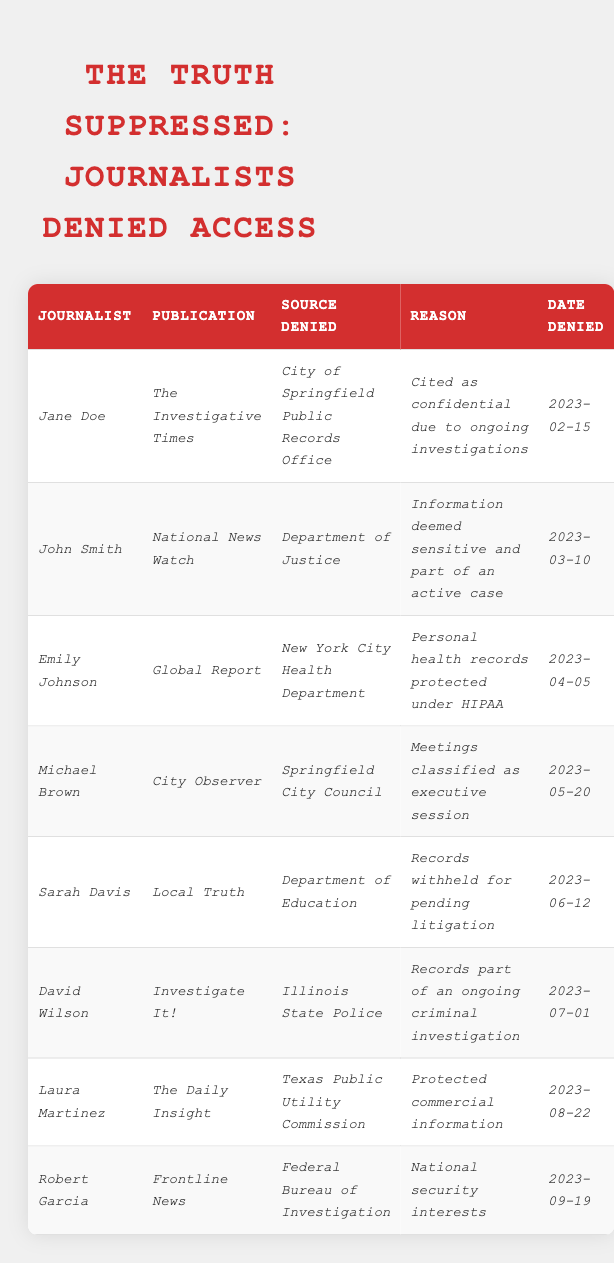What is the name of the journalist denied access by the Illinois State Police? The table lists journalists along with their denied access sources. For the Illinois State Police, the corresponding journalist is David Wilson.
Answer: David Wilson Which publication does Sarah Davis work for? By examining the table, Sarah Davis is shown to be associated with "Local Truth".
Answer: Local Truth How many journalists were denied access to sources in the year 2023? The table contains a list of 8 journalists, all of whom were denied access in 2023, as all dates are in that year.
Answer: 8 What reason was given for denying Jane Doe access to public records? The table details that Jane Doe was denied access because the records were "cited as confidential due to ongoing investigations".
Answer: Cited as confidential due to ongoing investigations Is the reason for denying access to the New York City Health Department related to HIPAA? Looking at the table, it states that Emily Johnson was denied access to the New York City Health Department due to "personal health records protected under HIPAA". Therefore, the answer is yes.
Answer: Yes List the sources that were denied access to public records by journalists in May 2023 or later. From the table, I will filter the dates; Michael Brown denied access in May 2023 and Sarah Davis, David Wilson, Laura Martinez, and Robert Garcia afterwards. The sources are the Springfield City Council, Department of Education, Illinois State Police, Texas Public Utility Commission, and the Federal Bureau of Investigation.
Answer: Springfield City Council, Department of Education, Illinois State Police, Texas Public Utility Commission, Federal Bureau of Investigation Which journalist was denied access on the earliest date among the listed incidents? We can refer to the "Date Denied" column in the table. The earliest date mentioned is February 15, 2023, belonging to Jane Doe.
Answer: Jane Doe What is the total number of denied access incidents due to ongoing investigations? The table shows two incidents related to ongoing investigations: one for Jane Doe with the Springfield Public Records Office and another for David Wilson with Illinois State Police.
Answer: 2 Which publication faced denied access related to national security interests? The table indicates that Robert Garcia from "Frontline News" was denied access due to national security interests, as per the corresponding entry.
Answer: Frontline News What was the most frequently cited reason for denial of access among the journalists listed? Examining the reasons, "ongoing investigations" and "protected personal information" appear twice among the reasons. However, each specific reason has a unique description. Thus, the most common reason in different variations appears to be associated with active investigations.
Answer: Ongoing investigations Were any journalists denied access to records related to education? Sarah Davis was denied records from the Department of Education, confirming the answer is yes.
Answer: Yes 